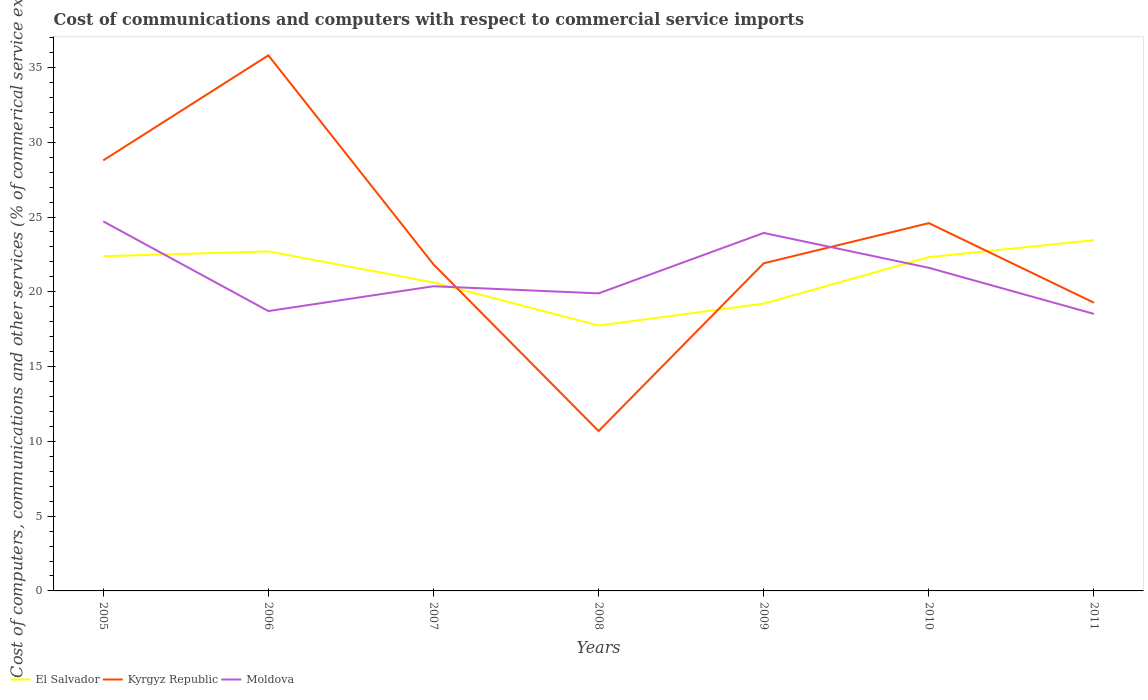How many different coloured lines are there?
Your response must be concise. 3. Across all years, what is the maximum cost of communications and computers in Moldova?
Offer a very short reply. 18.52. What is the total cost of communications and computers in Moldova in the graph?
Offer a very short reply. 1.37. What is the difference between the highest and the second highest cost of communications and computers in Moldova?
Offer a very short reply. 6.19. What is the difference between the highest and the lowest cost of communications and computers in El Salvador?
Provide a short and direct response. 4. What is the difference between two consecutive major ticks on the Y-axis?
Offer a very short reply. 5. Does the graph contain any zero values?
Keep it short and to the point. No. Where does the legend appear in the graph?
Make the answer very short. Bottom left. What is the title of the graph?
Make the answer very short. Cost of communications and computers with respect to commercial service imports. What is the label or title of the Y-axis?
Your response must be concise. Cost of computers, communications and other services (% of commerical service exports). What is the Cost of computers, communications and other services (% of commerical service exports) of El Salvador in 2005?
Your answer should be very brief. 22.38. What is the Cost of computers, communications and other services (% of commerical service exports) of Kyrgyz Republic in 2005?
Provide a short and direct response. 28.79. What is the Cost of computers, communications and other services (% of commerical service exports) of Moldova in 2005?
Give a very brief answer. 24.71. What is the Cost of computers, communications and other services (% of commerical service exports) of El Salvador in 2006?
Provide a succinct answer. 22.7. What is the Cost of computers, communications and other services (% of commerical service exports) in Kyrgyz Republic in 2006?
Your response must be concise. 35.81. What is the Cost of computers, communications and other services (% of commerical service exports) of Moldova in 2006?
Make the answer very short. 18.71. What is the Cost of computers, communications and other services (% of commerical service exports) of El Salvador in 2007?
Your response must be concise. 20.63. What is the Cost of computers, communications and other services (% of commerical service exports) in Kyrgyz Republic in 2007?
Offer a very short reply. 21.83. What is the Cost of computers, communications and other services (% of commerical service exports) in Moldova in 2007?
Provide a short and direct response. 20.37. What is the Cost of computers, communications and other services (% of commerical service exports) in El Salvador in 2008?
Your response must be concise. 17.74. What is the Cost of computers, communications and other services (% of commerical service exports) in Kyrgyz Republic in 2008?
Offer a very short reply. 10.69. What is the Cost of computers, communications and other services (% of commerical service exports) of Moldova in 2008?
Provide a short and direct response. 19.9. What is the Cost of computers, communications and other services (% of commerical service exports) in El Salvador in 2009?
Your answer should be very brief. 19.21. What is the Cost of computers, communications and other services (% of commerical service exports) in Kyrgyz Republic in 2009?
Make the answer very short. 21.91. What is the Cost of computers, communications and other services (% of commerical service exports) in Moldova in 2009?
Make the answer very short. 23.94. What is the Cost of computers, communications and other services (% of commerical service exports) in El Salvador in 2010?
Offer a very short reply. 22.32. What is the Cost of computers, communications and other services (% of commerical service exports) of Kyrgyz Republic in 2010?
Give a very brief answer. 24.59. What is the Cost of computers, communications and other services (% of commerical service exports) in Moldova in 2010?
Provide a short and direct response. 21.6. What is the Cost of computers, communications and other services (% of commerical service exports) of El Salvador in 2011?
Provide a succinct answer. 23.45. What is the Cost of computers, communications and other services (% of commerical service exports) in Kyrgyz Republic in 2011?
Make the answer very short. 19.27. What is the Cost of computers, communications and other services (% of commerical service exports) of Moldova in 2011?
Offer a very short reply. 18.52. Across all years, what is the maximum Cost of computers, communications and other services (% of commerical service exports) in El Salvador?
Your answer should be very brief. 23.45. Across all years, what is the maximum Cost of computers, communications and other services (% of commerical service exports) in Kyrgyz Republic?
Make the answer very short. 35.81. Across all years, what is the maximum Cost of computers, communications and other services (% of commerical service exports) in Moldova?
Your answer should be very brief. 24.71. Across all years, what is the minimum Cost of computers, communications and other services (% of commerical service exports) in El Salvador?
Your answer should be very brief. 17.74. Across all years, what is the minimum Cost of computers, communications and other services (% of commerical service exports) in Kyrgyz Republic?
Give a very brief answer. 10.69. Across all years, what is the minimum Cost of computers, communications and other services (% of commerical service exports) in Moldova?
Ensure brevity in your answer.  18.52. What is the total Cost of computers, communications and other services (% of commerical service exports) in El Salvador in the graph?
Your response must be concise. 148.43. What is the total Cost of computers, communications and other services (% of commerical service exports) of Kyrgyz Republic in the graph?
Provide a short and direct response. 162.88. What is the total Cost of computers, communications and other services (% of commerical service exports) in Moldova in the graph?
Ensure brevity in your answer.  147.75. What is the difference between the Cost of computers, communications and other services (% of commerical service exports) of El Salvador in 2005 and that in 2006?
Make the answer very short. -0.32. What is the difference between the Cost of computers, communications and other services (% of commerical service exports) in Kyrgyz Republic in 2005 and that in 2006?
Offer a terse response. -7.02. What is the difference between the Cost of computers, communications and other services (% of commerical service exports) of Moldova in 2005 and that in 2006?
Offer a very short reply. 6. What is the difference between the Cost of computers, communications and other services (% of commerical service exports) in El Salvador in 2005 and that in 2007?
Offer a very short reply. 1.75. What is the difference between the Cost of computers, communications and other services (% of commerical service exports) in Kyrgyz Republic in 2005 and that in 2007?
Your answer should be compact. 6.95. What is the difference between the Cost of computers, communications and other services (% of commerical service exports) of Moldova in 2005 and that in 2007?
Ensure brevity in your answer.  4.34. What is the difference between the Cost of computers, communications and other services (% of commerical service exports) of El Salvador in 2005 and that in 2008?
Provide a succinct answer. 4.64. What is the difference between the Cost of computers, communications and other services (% of commerical service exports) in Kyrgyz Republic in 2005 and that in 2008?
Ensure brevity in your answer.  18.1. What is the difference between the Cost of computers, communications and other services (% of commerical service exports) of Moldova in 2005 and that in 2008?
Ensure brevity in your answer.  4.81. What is the difference between the Cost of computers, communications and other services (% of commerical service exports) of El Salvador in 2005 and that in 2009?
Provide a short and direct response. 3.17. What is the difference between the Cost of computers, communications and other services (% of commerical service exports) in Kyrgyz Republic in 2005 and that in 2009?
Offer a terse response. 6.88. What is the difference between the Cost of computers, communications and other services (% of commerical service exports) of Moldova in 2005 and that in 2009?
Make the answer very short. 0.77. What is the difference between the Cost of computers, communications and other services (% of commerical service exports) in El Salvador in 2005 and that in 2010?
Give a very brief answer. 0.06. What is the difference between the Cost of computers, communications and other services (% of commerical service exports) in Kyrgyz Republic in 2005 and that in 2010?
Keep it short and to the point. 4.19. What is the difference between the Cost of computers, communications and other services (% of commerical service exports) in Moldova in 2005 and that in 2010?
Offer a very short reply. 3.1. What is the difference between the Cost of computers, communications and other services (% of commerical service exports) of El Salvador in 2005 and that in 2011?
Provide a succinct answer. -1.07. What is the difference between the Cost of computers, communications and other services (% of commerical service exports) in Kyrgyz Republic in 2005 and that in 2011?
Your response must be concise. 9.52. What is the difference between the Cost of computers, communications and other services (% of commerical service exports) in Moldova in 2005 and that in 2011?
Ensure brevity in your answer.  6.19. What is the difference between the Cost of computers, communications and other services (% of commerical service exports) of El Salvador in 2006 and that in 2007?
Offer a very short reply. 2.07. What is the difference between the Cost of computers, communications and other services (% of commerical service exports) of Kyrgyz Republic in 2006 and that in 2007?
Provide a short and direct response. 13.98. What is the difference between the Cost of computers, communications and other services (% of commerical service exports) of Moldova in 2006 and that in 2007?
Offer a terse response. -1.66. What is the difference between the Cost of computers, communications and other services (% of commerical service exports) of El Salvador in 2006 and that in 2008?
Your answer should be compact. 4.96. What is the difference between the Cost of computers, communications and other services (% of commerical service exports) in Kyrgyz Republic in 2006 and that in 2008?
Give a very brief answer. 25.12. What is the difference between the Cost of computers, communications and other services (% of commerical service exports) in Moldova in 2006 and that in 2008?
Ensure brevity in your answer.  -1.18. What is the difference between the Cost of computers, communications and other services (% of commerical service exports) in El Salvador in 2006 and that in 2009?
Offer a very short reply. 3.49. What is the difference between the Cost of computers, communications and other services (% of commerical service exports) of Kyrgyz Republic in 2006 and that in 2009?
Keep it short and to the point. 13.9. What is the difference between the Cost of computers, communications and other services (% of commerical service exports) in Moldova in 2006 and that in 2009?
Offer a very short reply. -5.22. What is the difference between the Cost of computers, communications and other services (% of commerical service exports) in El Salvador in 2006 and that in 2010?
Provide a succinct answer. 0.38. What is the difference between the Cost of computers, communications and other services (% of commerical service exports) in Kyrgyz Republic in 2006 and that in 2010?
Provide a short and direct response. 11.22. What is the difference between the Cost of computers, communications and other services (% of commerical service exports) of Moldova in 2006 and that in 2010?
Provide a short and direct response. -2.89. What is the difference between the Cost of computers, communications and other services (% of commerical service exports) in El Salvador in 2006 and that in 2011?
Offer a terse response. -0.75. What is the difference between the Cost of computers, communications and other services (% of commerical service exports) of Kyrgyz Republic in 2006 and that in 2011?
Your response must be concise. 16.54. What is the difference between the Cost of computers, communications and other services (% of commerical service exports) of Moldova in 2006 and that in 2011?
Provide a short and direct response. 0.19. What is the difference between the Cost of computers, communications and other services (% of commerical service exports) of El Salvador in 2007 and that in 2008?
Make the answer very short. 2.88. What is the difference between the Cost of computers, communications and other services (% of commerical service exports) in Kyrgyz Republic in 2007 and that in 2008?
Ensure brevity in your answer.  11.15. What is the difference between the Cost of computers, communications and other services (% of commerical service exports) of Moldova in 2007 and that in 2008?
Provide a succinct answer. 0.48. What is the difference between the Cost of computers, communications and other services (% of commerical service exports) in El Salvador in 2007 and that in 2009?
Provide a succinct answer. 1.42. What is the difference between the Cost of computers, communications and other services (% of commerical service exports) in Kyrgyz Republic in 2007 and that in 2009?
Your answer should be compact. -0.07. What is the difference between the Cost of computers, communications and other services (% of commerical service exports) of Moldova in 2007 and that in 2009?
Keep it short and to the point. -3.56. What is the difference between the Cost of computers, communications and other services (% of commerical service exports) in El Salvador in 2007 and that in 2010?
Provide a succinct answer. -1.69. What is the difference between the Cost of computers, communications and other services (% of commerical service exports) of Kyrgyz Republic in 2007 and that in 2010?
Provide a short and direct response. -2.76. What is the difference between the Cost of computers, communications and other services (% of commerical service exports) of Moldova in 2007 and that in 2010?
Provide a short and direct response. -1.23. What is the difference between the Cost of computers, communications and other services (% of commerical service exports) of El Salvador in 2007 and that in 2011?
Provide a succinct answer. -2.83. What is the difference between the Cost of computers, communications and other services (% of commerical service exports) in Kyrgyz Republic in 2007 and that in 2011?
Keep it short and to the point. 2.56. What is the difference between the Cost of computers, communications and other services (% of commerical service exports) of Moldova in 2007 and that in 2011?
Your answer should be very brief. 1.85. What is the difference between the Cost of computers, communications and other services (% of commerical service exports) of El Salvador in 2008 and that in 2009?
Offer a terse response. -1.47. What is the difference between the Cost of computers, communications and other services (% of commerical service exports) in Kyrgyz Republic in 2008 and that in 2009?
Your response must be concise. -11.22. What is the difference between the Cost of computers, communications and other services (% of commerical service exports) in Moldova in 2008 and that in 2009?
Offer a very short reply. -4.04. What is the difference between the Cost of computers, communications and other services (% of commerical service exports) in El Salvador in 2008 and that in 2010?
Provide a short and direct response. -4.57. What is the difference between the Cost of computers, communications and other services (% of commerical service exports) of Kyrgyz Republic in 2008 and that in 2010?
Make the answer very short. -13.9. What is the difference between the Cost of computers, communications and other services (% of commerical service exports) in Moldova in 2008 and that in 2010?
Give a very brief answer. -1.71. What is the difference between the Cost of computers, communications and other services (% of commerical service exports) in El Salvador in 2008 and that in 2011?
Make the answer very short. -5.71. What is the difference between the Cost of computers, communications and other services (% of commerical service exports) of Kyrgyz Republic in 2008 and that in 2011?
Keep it short and to the point. -8.58. What is the difference between the Cost of computers, communications and other services (% of commerical service exports) in Moldova in 2008 and that in 2011?
Ensure brevity in your answer.  1.37. What is the difference between the Cost of computers, communications and other services (% of commerical service exports) in El Salvador in 2009 and that in 2010?
Give a very brief answer. -3.11. What is the difference between the Cost of computers, communications and other services (% of commerical service exports) of Kyrgyz Republic in 2009 and that in 2010?
Give a very brief answer. -2.69. What is the difference between the Cost of computers, communications and other services (% of commerical service exports) in Moldova in 2009 and that in 2010?
Offer a very short reply. 2.33. What is the difference between the Cost of computers, communications and other services (% of commerical service exports) of El Salvador in 2009 and that in 2011?
Offer a terse response. -4.24. What is the difference between the Cost of computers, communications and other services (% of commerical service exports) in Kyrgyz Republic in 2009 and that in 2011?
Make the answer very short. 2.64. What is the difference between the Cost of computers, communications and other services (% of commerical service exports) in Moldova in 2009 and that in 2011?
Make the answer very short. 5.41. What is the difference between the Cost of computers, communications and other services (% of commerical service exports) in El Salvador in 2010 and that in 2011?
Your answer should be very brief. -1.14. What is the difference between the Cost of computers, communications and other services (% of commerical service exports) in Kyrgyz Republic in 2010 and that in 2011?
Offer a very short reply. 5.32. What is the difference between the Cost of computers, communications and other services (% of commerical service exports) of Moldova in 2010 and that in 2011?
Offer a very short reply. 3.08. What is the difference between the Cost of computers, communications and other services (% of commerical service exports) in El Salvador in 2005 and the Cost of computers, communications and other services (% of commerical service exports) in Kyrgyz Republic in 2006?
Give a very brief answer. -13.43. What is the difference between the Cost of computers, communications and other services (% of commerical service exports) in El Salvador in 2005 and the Cost of computers, communications and other services (% of commerical service exports) in Moldova in 2006?
Provide a succinct answer. 3.67. What is the difference between the Cost of computers, communications and other services (% of commerical service exports) in Kyrgyz Republic in 2005 and the Cost of computers, communications and other services (% of commerical service exports) in Moldova in 2006?
Give a very brief answer. 10.07. What is the difference between the Cost of computers, communications and other services (% of commerical service exports) in El Salvador in 2005 and the Cost of computers, communications and other services (% of commerical service exports) in Kyrgyz Republic in 2007?
Provide a succinct answer. 0.55. What is the difference between the Cost of computers, communications and other services (% of commerical service exports) in El Salvador in 2005 and the Cost of computers, communications and other services (% of commerical service exports) in Moldova in 2007?
Keep it short and to the point. 2.01. What is the difference between the Cost of computers, communications and other services (% of commerical service exports) of Kyrgyz Republic in 2005 and the Cost of computers, communications and other services (% of commerical service exports) of Moldova in 2007?
Keep it short and to the point. 8.41. What is the difference between the Cost of computers, communications and other services (% of commerical service exports) of El Salvador in 2005 and the Cost of computers, communications and other services (% of commerical service exports) of Kyrgyz Republic in 2008?
Your answer should be very brief. 11.69. What is the difference between the Cost of computers, communications and other services (% of commerical service exports) of El Salvador in 2005 and the Cost of computers, communications and other services (% of commerical service exports) of Moldova in 2008?
Give a very brief answer. 2.48. What is the difference between the Cost of computers, communications and other services (% of commerical service exports) of Kyrgyz Republic in 2005 and the Cost of computers, communications and other services (% of commerical service exports) of Moldova in 2008?
Offer a very short reply. 8.89. What is the difference between the Cost of computers, communications and other services (% of commerical service exports) in El Salvador in 2005 and the Cost of computers, communications and other services (% of commerical service exports) in Kyrgyz Republic in 2009?
Your answer should be compact. 0.47. What is the difference between the Cost of computers, communications and other services (% of commerical service exports) in El Salvador in 2005 and the Cost of computers, communications and other services (% of commerical service exports) in Moldova in 2009?
Give a very brief answer. -1.56. What is the difference between the Cost of computers, communications and other services (% of commerical service exports) of Kyrgyz Republic in 2005 and the Cost of computers, communications and other services (% of commerical service exports) of Moldova in 2009?
Offer a terse response. 4.85. What is the difference between the Cost of computers, communications and other services (% of commerical service exports) of El Salvador in 2005 and the Cost of computers, communications and other services (% of commerical service exports) of Kyrgyz Republic in 2010?
Offer a terse response. -2.21. What is the difference between the Cost of computers, communications and other services (% of commerical service exports) in El Salvador in 2005 and the Cost of computers, communications and other services (% of commerical service exports) in Moldova in 2010?
Your answer should be compact. 0.78. What is the difference between the Cost of computers, communications and other services (% of commerical service exports) in Kyrgyz Republic in 2005 and the Cost of computers, communications and other services (% of commerical service exports) in Moldova in 2010?
Your response must be concise. 7.18. What is the difference between the Cost of computers, communications and other services (% of commerical service exports) of El Salvador in 2005 and the Cost of computers, communications and other services (% of commerical service exports) of Kyrgyz Republic in 2011?
Offer a very short reply. 3.11. What is the difference between the Cost of computers, communications and other services (% of commerical service exports) in El Salvador in 2005 and the Cost of computers, communications and other services (% of commerical service exports) in Moldova in 2011?
Offer a terse response. 3.86. What is the difference between the Cost of computers, communications and other services (% of commerical service exports) in Kyrgyz Republic in 2005 and the Cost of computers, communications and other services (% of commerical service exports) in Moldova in 2011?
Your answer should be very brief. 10.26. What is the difference between the Cost of computers, communications and other services (% of commerical service exports) in El Salvador in 2006 and the Cost of computers, communications and other services (% of commerical service exports) in Kyrgyz Republic in 2007?
Give a very brief answer. 0.87. What is the difference between the Cost of computers, communications and other services (% of commerical service exports) of El Salvador in 2006 and the Cost of computers, communications and other services (% of commerical service exports) of Moldova in 2007?
Offer a very short reply. 2.33. What is the difference between the Cost of computers, communications and other services (% of commerical service exports) in Kyrgyz Republic in 2006 and the Cost of computers, communications and other services (% of commerical service exports) in Moldova in 2007?
Provide a succinct answer. 15.44. What is the difference between the Cost of computers, communications and other services (% of commerical service exports) in El Salvador in 2006 and the Cost of computers, communications and other services (% of commerical service exports) in Kyrgyz Republic in 2008?
Keep it short and to the point. 12.01. What is the difference between the Cost of computers, communications and other services (% of commerical service exports) of El Salvador in 2006 and the Cost of computers, communications and other services (% of commerical service exports) of Moldova in 2008?
Ensure brevity in your answer.  2.81. What is the difference between the Cost of computers, communications and other services (% of commerical service exports) in Kyrgyz Republic in 2006 and the Cost of computers, communications and other services (% of commerical service exports) in Moldova in 2008?
Keep it short and to the point. 15.91. What is the difference between the Cost of computers, communications and other services (% of commerical service exports) of El Salvador in 2006 and the Cost of computers, communications and other services (% of commerical service exports) of Kyrgyz Republic in 2009?
Keep it short and to the point. 0.79. What is the difference between the Cost of computers, communications and other services (% of commerical service exports) of El Salvador in 2006 and the Cost of computers, communications and other services (% of commerical service exports) of Moldova in 2009?
Your response must be concise. -1.23. What is the difference between the Cost of computers, communications and other services (% of commerical service exports) in Kyrgyz Republic in 2006 and the Cost of computers, communications and other services (% of commerical service exports) in Moldova in 2009?
Provide a short and direct response. 11.87. What is the difference between the Cost of computers, communications and other services (% of commerical service exports) in El Salvador in 2006 and the Cost of computers, communications and other services (% of commerical service exports) in Kyrgyz Republic in 2010?
Your answer should be compact. -1.89. What is the difference between the Cost of computers, communications and other services (% of commerical service exports) of El Salvador in 2006 and the Cost of computers, communications and other services (% of commerical service exports) of Moldova in 2010?
Keep it short and to the point. 1.1. What is the difference between the Cost of computers, communications and other services (% of commerical service exports) of Kyrgyz Republic in 2006 and the Cost of computers, communications and other services (% of commerical service exports) of Moldova in 2010?
Offer a terse response. 14.2. What is the difference between the Cost of computers, communications and other services (% of commerical service exports) in El Salvador in 2006 and the Cost of computers, communications and other services (% of commerical service exports) in Kyrgyz Republic in 2011?
Your answer should be very brief. 3.43. What is the difference between the Cost of computers, communications and other services (% of commerical service exports) of El Salvador in 2006 and the Cost of computers, communications and other services (% of commerical service exports) of Moldova in 2011?
Keep it short and to the point. 4.18. What is the difference between the Cost of computers, communications and other services (% of commerical service exports) of Kyrgyz Republic in 2006 and the Cost of computers, communications and other services (% of commerical service exports) of Moldova in 2011?
Ensure brevity in your answer.  17.29. What is the difference between the Cost of computers, communications and other services (% of commerical service exports) of El Salvador in 2007 and the Cost of computers, communications and other services (% of commerical service exports) of Kyrgyz Republic in 2008?
Make the answer very short. 9.94. What is the difference between the Cost of computers, communications and other services (% of commerical service exports) of El Salvador in 2007 and the Cost of computers, communications and other services (% of commerical service exports) of Moldova in 2008?
Keep it short and to the point. 0.73. What is the difference between the Cost of computers, communications and other services (% of commerical service exports) of Kyrgyz Republic in 2007 and the Cost of computers, communications and other services (% of commerical service exports) of Moldova in 2008?
Keep it short and to the point. 1.94. What is the difference between the Cost of computers, communications and other services (% of commerical service exports) of El Salvador in 2007 and the Cost of computers, communications and other services (% of commerical service exports) of Kyrgyz Republic in 2009?
Your response must be concise. -1.28. What is the difference between the Cost of computers, communications and other services (% of commerical service exports) of El Salvador in 2007 and the Cost of computers, communications and other services (% of commerical service exports) of Moldova in 2009?
Ensure brevity in your answer.  -3.31. What is the difference between the Cost of computers, communications and other services (% of commerical service exports) of Kyrgyz Republic in 2007 and the Cost of computers, communications and other services (% of commerical service exports) of Moldova in 2009?
Provide a short and direct response. -2.1. What is the difference between the Cost of computers, communications and other services (% of commerical service exports) of El Salvador in 2007 and the Cost of computers, communications and other services (% of commerical service exports) of Kyrgyz Republic in 2010?
Provide a short and direct response. -3.96. What is the difference between the Cost of computers, communications and other services (% of commerical service exports) of El Salvador in 2007 and the Cost of computers, communications and other services (% of commerical service exports) of Moldova in 2010?
Offer a very short reply. -0.98. What is the difference between the Cost of computers, communications and other services (% of commerical service exports) in Kyrgyz Republic in 2007 and the Cost of computers, communications and other services (% of commerical service exports) in Moldova in 2010?
Your answer should be very brief. 0.23. What is the difference between the Cost of computers, communications and other services (% of commerical service exports) of El Salvador in 2007 and the Cost of computers, communications and other services (% of commerical service exports) of Kyrgyz Republic in 2011?
Keep it short and to the point. 1.36. What is the difference between the Cost of computers, communications and other services (% of commerical service exports) in El Salvador in 2007 and the Cost of computers, communications and other services (% of commerical service exports) in Moldova in 2011?
Your answer should be compact. 2.1. What is the difference between the Cost of computers, communications and other services (% of commerical service exports) in Kyrgyz Republic in 2007 and the Cost of computers, communications and other services (% of commerical service exports) in Moldova in 2011?
Offer a terse response. 3.31. What is the difference between the Cost of computers, communications and other services (% of commerical service exports) in El Salvador in 2008 and the Cost of computers, communications and other services (% of commerical service exports) in Kyrgyz Republic in 2009?
Your answer should be compact. -4.16. What is the difference between the Cost of computers, communications and other services (% of commerical service exports) in El Salvador in 2008 and the Cost of computers, communications and other services (% of commerical service exports) in Moldova in 2009?
Offer a terse response. -6.19. What is the difference between the Cost of computers, communications and other services (% of commerical service exports) of Kyrgyz Republic in 2008 and the Cost of computers, communications and other services (% of commerical service exports) of Moldova in 2009?
Offer a very short reply. -13.25. What is the difference between the Cost of computers, communications and other services (% of commerical service exports) in El Salvador in 2008 and the Cost of computers, communications and other services (% of commerical service exports) in Kyrgyz Republic in 2010?
Offer a very short reply. -6.85. What is the difference between the Cost of computers, communications and other services (% of commerical service exports) in El Salvador in 2008 and the Cost of computers, communications and other services (% of commerical service exports) in Moldova in 2010?
Make the answer very short. -3.86. What is the difference between the Cost of computers, communications and other services (% of commerical service exports) of Kyrgyz Republic in 2008 and the Cost of computers, communications and other services (% of commerical service exports) of Moldova in 2010?
Your response must be concise. -10.92. What is the difference between the Cost of computers, communications and other services (% of commerical service exports) in El Salvador in 2008 and the Cost of computers, communications and other services (% of commerical service exports) in Kyrgyz Republic in 2011?
Offer a terse response. -1.53. What is the difference between the Cost of computers, communications and other services (% of commerical service exports) of El Salvador in 2008 and the Cost of computers, communications and other services (% of commerical service exports) of Moldova in 2011?
Your answer should be compact. -0.78. What is the difference between the Cost of computers, communications and other services (% of commerical service exports) in Kyrgyz Republic in 2008 and the Cost of computers, communications and other services (% of commerical service exports) in Moldova in 2011?
Ensure brevity in your answer.  -7.83. What is the difference between the Cost of computers, communications and other services (% of commerical service exports) of El Salvador in 2009 and the Cost of computers, communications and other services (% of commerical service exports) of Kyrgyz Republic in 2010?
Offer a terse response. -5.38. What is the difference between the Cost of computers, communications and other services (% of commerical service exports) in El Salvador in 2009 and the Cost of computers, communications and other services (% of commerical service exports) in Moldova in 2010?
Keep it short and to the point. -2.39. What is the difference between the Cost of computers, communications and other services (% of commerical service exports) of Kyrgyz Republic in 2009 and the Cost of computers, communications and other services (% of commerical service exports) of Moldova in 2010?
Provide a short and direct response. 0.3. What is the difference between the Cost of computers, communications and other services (% of commerical service exports) in El Salvador in 2009 and the Cost of computers, communications and other services (% of commerical service exports) in Kyrgyz Republic in 2011?
Keep it short and to the point. -0.06. What is the difference between the Cost of computers, communications and other services (% of commerical service exports) in El Salvador in 2009 and the Cost of computers, communications and other services (% of commerical service exports) in Moldova in 2011?
Your answer should be very brief. 0.69. What is the difference between the Cost of computers, communications and other services (% of commerical service exports) of Kyrgyz Republic in 2009 and the Cost of computers, communications and other services (% of commerical service exports) of Moldova in 2011?
Your answer should be compact. 3.38. What is the difference between the Cost of computers, communications and other services (% of commerical service exports) in El Salvador in 2010 and the Cost of computers, communications and other services (% of commerical service exports) in Kyrgyz Republic in 2011?
Give a very brief answer. 3.05. What is the difference between the Cost of computers, communications and other services (% of commerical service exports) in El Salvador in 2010 and the Cost of computers, communications and other services (% of commerical service exports) in Moldova in 2011?
Make the answer very short. 3.79. What is the difference between the Cost of computers, communications and other services (% of commerical service exports) in Kyrgyz Republic in 2010 and the Cost of computers, communications and other services (% of commerical service exports) in Moldova in 2011?
Ensure brevity in your answer.  6.07. What is the average Cost of computers, communications and other services (% of commerical service exports) of El Salvador per year?
Your answer should be very brief. 21.2. What is the average Cost of computers, communications and other services (% of commerical service exports) in Kyrgyz Republic per year?
Ensure brevity in your answer.  23.27. What is the average Cost of computers, communications and other services (% of commerical service exports) of Moldova per year?
Ensure brevity in your answer.  21.11. In the year 2005, what is the difference between the Cost of computers, communications and other services (% of commerical service exports) in El Salvador and Cost of computers, communications and other services (% of commerical service exports) in Kyrgyz Republic?
Your response must be concise. -6.41. In the year 2005, what is the difference between the Cost of computers, communications and other services (% of commerical service exports) of El Salvador and Cost of computers, communications and other services (% of commerical service exports) of Moldova?
Provide a succinct answer. -2.33. In the year 2005, what is the difference between the Cost of computers, communications and other services (% of commerical service exports) of Kyrgyz Republic and Cost of computers, communications and other services (% of commerical service exports) of Moldova?
Offer a very short reply. 4.08. In the year 2006, what is the difference between the Cost of computers, communications and other services (% of commerical service exports) of El Salvador and Cost of computers, communications and other services (% of commerical service exports) of Kyrgyz Republic?
Offer a terse response. -13.11. In the year 2006, what is the difference between the Cost of computers, communications and other services (% of commerical service exports) of El Salvador and Cost of computers, communications and other services (% of commerical service exports) of Moldova?
Offer a very short reply. 3.99. In the year 2006, what is the difference between the Cost of computers, communications and other services (% of commerical service exports) of Kyrgyz Republic and Cost of computers, communications and other services (% of commerical service exports) of Moldova?
Offer a terse response. 17.1. In the year 2007, what is the difference between the Cost of computers, communications and other services (% of commerical service exports) in El Salvador and Cost of computers, communications and other services (% of commerical service exports) in Kyrgyz Republic?
Your answer should be very brief. -1.21. In the year 2007, what is the difference between the Cost of computers, communications and other services (% of commerical service exports) in El Salvador and Cost of computers, communications and other services (% of commerical service exports) in Moldova?
Give a very brief answer. 0.26. In the year 2007, what is the difference between the Cost of computers, communications and other services (% of commerical service exports) in Kyrgyz Republic and Cost of computers, communications and other services (% of commerical service exports) in Moldova?
Provide a short and direct response. 1.46. In the year 2008, what is the difference between the Cost of computers, communications and other services (% of commerical service exports) in El Salvador and Cost of computers, communications and other services (% of commerical service exports) in Kyrgyz Republic?
Your answer should be compact. 7.05. In the year 2008, what is the difference between the Cost of computers, communications and other services (% of commerical service exports) in El Salvador and Cost of computers, communications and other services (% of commerical service exports) in Moldova?
Your answer should be compact. -2.15. In the year 2008, what is the difference between the Cost of computers, communications and other services (% of commerical service exports) in Kyrgyz Republic and Cost of computers, communications and other services (% of commerical service exports) in Moldova?
Provide a short and direct response. -9.21. In the year 2009, what is the difference between the Cost of computers, communications and other services (% of commerical service exports) in El Salvador and Cost of computers, communications and other services (% of commerical service exports) in Kyrgyz Republic?
Your response must be concise. -2.7. In the year 2009, what is the difference between the Cost of computers, communications and other services (% of commerical service exports) of El Salvador and Cost of computers, communications and other services (% of commerical service exports) of Moldova?
Give a very brief answer. -4.72. In the year 2009, what is the difference between the Cost of computers, communications and other services (% of commerical service exports) in Kyrgyz Republic and Cost of computers, communications and other services (% of commerical service exports) in Moldova?
Make the answer very short. -2.03. In the year 2010, what is the difference between the Cost of computers, communications and other services (% of commerical service exports) of El Salvador and Cost of computers, communications and other services (% of commerical service exports) of Kyrgyz Republic?
Offer a very short reply. -2.28. In the year 2010, what is the difference between the Cost of computers, communications and other services (% of commerical service exports) in El Salvador and Cost of computers, communications and other services (% of commerical service exports) in Moldova?
Your answer should be compact. 0.71. In the year 2010, what is the difference between the Cost of computers, communications and other services (% of commerical service exports) of Kyrgyz Republic and Cost of computers, communications and other services (% of commerical service exports) of Moldova?
Keep it short and to the point. 2.99. In the year 2011, what is the difference between the Cost of computers, communications and other services (% of commerical service exports) of El Salvador and Cost of computers, communications and other services (% of commerical service exports) of Kyrgyz Republic?
Provide a succinct answer. 4.18. In the year 2011, what is the difference between the Cost of computers, communications and other services (% of commerical service exports) of El Salvador and Cost of computers, communications and other services (% of commerical service exports) of Moldova?
Ensure brevity in your answer.  4.93. In the year 2011, what is the difference between the Cost of computers, communications and other services (% of commerical service exports) of Kyrgyz Republic and Cost of computers, communications and other services (% of commerical service exports) of Moldova?
Offer a very short reply. 0.75. What is the ratio of the Cost of computers, communications and other services (% of commerical service exports) of El Salvador in 2005 to that in 2006?
Provide a succinct answer. 0.99. What is the ratio of the Cost of computers, communications and other services (% of commerical service exports) of Kyrgyz Republic in 2005 to that in 2006?
Your response must be concise. 0.8. What is the ratio of the Cost of computers, communications and other services (% of commerical service exports) of Moldova in 2005 to that in 2006?
Your answer should be very brief. 1.32. What is the ratio of the Cost of computers, communications and other services (% of commerical service exports) in El Salvador in 2005 to that in 2007?
Your answer should be compact. 1.08. What is the ratio of the Cost of computers, communications and other services (% of commerical service exports) of Kyrgyz Republic in 2005 to that in 2007?
Provide a short and direct response. 1.32. What is the ratio of the Cost of computers, communications and other services (% of commerical service exports) in Moldova in 2005 to that in 2007?
Your answer should be very brief. 1.21. What is the ratio of the Cost of computers, communications and other services (% of commerical service exports) of El Salvador in 2005 to that in 2008?
Your response must be concise. 1.26. What is the ratio of the Cost of computers, communications and other services (% of commerical service exports) in Kyrgyz Republic in 2005 to that in 2008?
Provide a succinct answer. 2.69. What is the ratio of the Cost of computers, communications and other services (% of commerical service exports) of Moldova in 2005 to that in 2008?
Give a very brief answer. 1.24. What is the ratio of the Cost of computers, communications and other services (% of commerical service exports) of El Salvador in 2005 to that in 2009?
Offer a very short reply. 1.17. What is the ratio of the Cost of computers, communications and other services (% of commerical service exports) in Kyrgyz Republic in 2005 to that in 2009?
Provide a succinct answer. 1.31. What is the ratio of the Cost of computers, communications and other services (% of commerical service exports) in Moldova in 2005 to that in 2009?
Offer a terse response. 1.03. What is the ratio of the Cost of computers, communications and other services (% of commerical service exports) in El Salvador in 2005 to that in 2010?
Make the answer very short. 1. What is the ratio of the Cost of computers, communications and other services (% of commerical service exports) of Kyrgyz Republic in 2005 to that in 2010?
Your answer should be compact. 1.17. What is the ratio of the Cost of computers, communications and other services (% of commerical service exports) of Moldova in 2005 to that in 2010?
Ensure brevity in your answer.  1.14. What is the ratio of the Cost of computers, communications and other services (% of commerical service exports) of El Salvador in 2005 to that in 2011?
Ensure brevity in your answer.  0.95. What is the ratio of the Cost of computers, communications and other services (% of commerical service exports) in Kyrgyz Republic in 2005 to that in 2011?
Your answer should be compact. 1.49. What is the ratio of the Cost of computers, communications and other services (% of commerical service exports) in Moldova in 2005 to that in 2011?
Your answer should be very brief. 1.33. What is the ratio of the Cost of computers, communications and other services (% of commerical service exports) in El Salvador in 2006 to that in 2007?
Provide a short and direct response. 1.1. What is the ratio of the Cost of computers, communications and other services (% of commerical service exports) of Kyrgyz Republic in 2006 to that in 2007?
Your answer should be compact. 1.64. What is the ratio of the Cost of computers, communications and other services (% of commerical service exports) in Moldova in 2006 to that in 2007?
Provide a short and direct response. 0.92. What is the ratio of the Cost of computers, communications and other services (% of commerical service exports) in El Salvador in 2006 to that in 2008?
Your answer should be compact. 1.28. What is the ratio of the Cost of computers, communications and other services (% of commerical service exports) of Kyrgyz Republic in 2006 to that in 2008?
Offer a very short reply. 3.35. What is the ratio of the Cost of computers, communications and other services (% of commerical service exports) in Moldova in 2006 to that in 2008?
Offer a terse response. 0.94. What is the ratio of the Cost of computers, communications and other services (% of commerical service exports) in El Salvador in 2006 to that in 2009?
Provide a short and direct response. 1.18. What is the ratio of the Cost of computers, communications and other services (% of commerical service exports) of Kyrgyz Republic in 2006 to that in 2009?
Provide a short and direct response. 1.63. What is the ratio of the Cost of computers, communications and other services (% of commerical service exports) in Moldova in 2006 to that in 2009?
Your answer should be very brief. 0.78. What is the ratio of the Cost of computers, communications and other services (% of commerical service exports) of El Salvador in 2006 to that in 2010?
Provide a succinct answer. 1.02. What is the ratio of the Cost of computers, communications and other services (% of commerical service exports) of Kyrgyz Republic in 2006 to that in 2010?
Offer a terse response. 1.46. What is the ratio of the Cost of computers, communications and other services (% of commerical service exports) of Moldova in 2006 to that in 2010?
Give a very brief answer. 0.87. What is the ratio of the Cost of computers, communications and other services (% of commerical service exports) in El Salvador in 2006 to that in 2011?
Your response must be concise. 0.97. What is the ratio of the Cost of computers, communications and other services (% of commerical service exports) in Kyrgyz Republic in 2006 to that in 2011?
Provide a short and direct response. 1.86. What is the ratio of the Cost of computers, communications and other services (% of commerical service exports) in Moldova in 2006 to that in 2011?
Provide a succinct answer. 1.01. What is the ratio of the Cost of computers, communications and other services (% of commerical service exports) in El Salvador in 2007 to that in 2008?
Your answer should be very brief. 1.16. What is the ratio of the Cost of computers, communications and other services (% of commerical service exports) of Kyrgyz Republic in 2007 to that in 2008?
Make the answer very short. 2.04. What is the ratio of the Cost of computers, communications and other services (% of commerical service exports) in Moldova in 2007 to that in 2008?
Your answer should be compact. 1.02. What is the ratio of the Cost of computers, communications and other services (% of commerical service exports) in El Salvador in 2007 to that in 2009?
Your response must be concise. 1.07. What is the ratio of the Cost of computers, communications and other services (% of commerical service exports) in Moldova in 2007 to that in 2009?
Offer a very short reply. 0.85. What is the ratio of the Cost of computers, communications and other services (% of commerical service exports) in El Salvador in 2007 to that in 2010?
Your answer should be very brief. 0.92. What is the ratio of the Cost of computers, communications and other services (% of commerical service exports) in Kyrgyz Republic in 2007 to that in 2010?
Provide a succinct answer. 0.89. What is the ratio of the Cost of computers, communications and other services (% of commerical service exports) in Moldova in 2007 to that in 2010?
Your answer should be very brief. 0.94. What is the ratio of the Cost of computers, communications and other services (% of commerical service exports) in El Salvador in 2007 to that in 2011?
Keep it short and to the point. 0.88. What is the ratio of the Cost of computers, communications and other services (% of commerical service exports) in Kyrgyz Republic in 2007 to that in 2011?
Make the answer very short. 1.13. What is the ratio of the Cost of computers, communications and other services (% of commerical service exports) in Moldova in 2007 to that in 2011?
Make the answer very short. 1.1. What is the ratio of the Cost of computers, communications and other services (% of commerical service exports) in El Salvador in 2008 to that in 2009?
Keep it short and to the point. 0.92. What is the ratio of the Cost of computers, communications and other services (% of commerical service exports) in Kyrgyz Republic in 2008 to that in 2009?
Ensure brevity in your answer.  0.49. What is the ratio of the Cost of computers, communications and other services (% of commerical service exports) in Moldova in 2008 to that in 2009?
Offer a terse response. 0.83. What is the ratio of the Cost of computers, communications and other services (% of commerical service exports) of El Salvador in 2008 to that in 2010?
Provide a succinct answer. 0.8. What is the ratio of the Cost of computers, communications and other services (% of commerical service exports) of Kyrgyz Republic in 2008 to that in 2010?
Keep it short and to the point. 0.43. What is the ratio of the Cost of computers, communications and other services (% of commerical service exports) in Moldova in 2008 to that in 2010?
Provide a short and direct response. 0.92. What is the ratio of the Cost of computers, communications and other services (% of commerical service exports) in El Salvador in 2008 to that in 2011?
Provide a short and direct response. 0.76. What is the ratio of the Cost of computers, communications and other services (% of commerical service exports) in Kyrgyz Republic in 2008 to that in 2011?
Provide a succinct answer. 0.55. What is the ratio of the Cost of computers, communications and other services (% of commerical service exports) of Moldova in 2008 to that in 2011?
Offer a very short reply. 1.07. What is the ratio of the Cost of computers, communications and other services (% of commerical service exports) of El Salvador in 2009 to that in 2010?
Provide a short and direct response. 0.86. What is the ratio of the Cost of computers, communications and other services (% of commerical service exports) of Kyrgyz Republic in 2009 to that in 2010?
Make the answer very short. 0.89. What is the ratio of the Cost of computers, communications and other services (% of commerical service exports) of Moldova in 2009 to that in 2010?
Offer a very short reply. 1.11. What is the ratio of the Cost of computers, communications and other services (% of commerical service exports) in El Salvador in 2009 to that in 2011?
Your answer should be compact. 0.82. What is the ratio of the Cost of computers, communications and other services (% of commerical service exports) in Kyrgyz Republic in 2009 to that in 2011?
Make the answer very short. 1.14. What is the ratio of the Cost of computers, communications and other services (% of commerical service exports) of Moldova in 2009 to that in 2011?
Your response must be concise. 1.29. What is the ratio of the Cost of computers, communications and other services (% of commerical service exports) in El Salvador in 2010 to that in 2011?
Offer a terse response. 0.95. What is the ratio of the Cost of computers, communications and other services (% of commerical service exports) in Kyrgyz Republic in 2010 to that in 2011?
Your answer should be very brief. 1.28. What is the ratio of the Cost of computers, communications and other services (% of commerical service exports) in Moldova in 2010 to that in 2011?
Make the answer very short. 1.17. What is the difference between the highest and the second highest Cost of computers, communications and other services (% of commerical service exports) in El Salvador?
Offer a very short reply. 0.75. What is the difference between the highest and the second highest Cost of computers, communications and other services (% of commerical service exports) of Kyrgyz Republic?
Offer a terse response. 7.02. What is the difference between the highest and the second highest Cost of computers, communications and other services (% of commerical service exports) in Moldova?
Offer a very short reply. 0.77. What is the difference between the highest and the lowest Cost of computers, communications and other services (% of commerical service exports) of El Salvador?
Offer a very short reply. 5.71. What is the difference between the highest and the lowest Cost of computers, communications and other services (% of commerical service exports) of Kyrgyz Republic?
Your response must be concise. 25.12. What is the difference between the highest and the lowest Cost of computers, communications and other services (% of commerical service exports) in Moldova?
Your response must be concise. 6.19. 